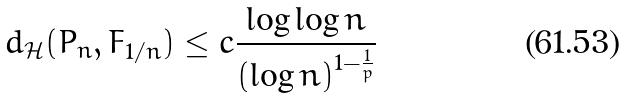Convert formula to latex. <formula><loc_0><loc_0><loc_500><loc_500>d _ { \mathcal { H } } ( P _ { n } , F _ { 1 / n } ) \leq c \frac { \log \log n } { \left ( \log n \right ) ^ { 1 - \frac { 1 } { p } } }</formula> 